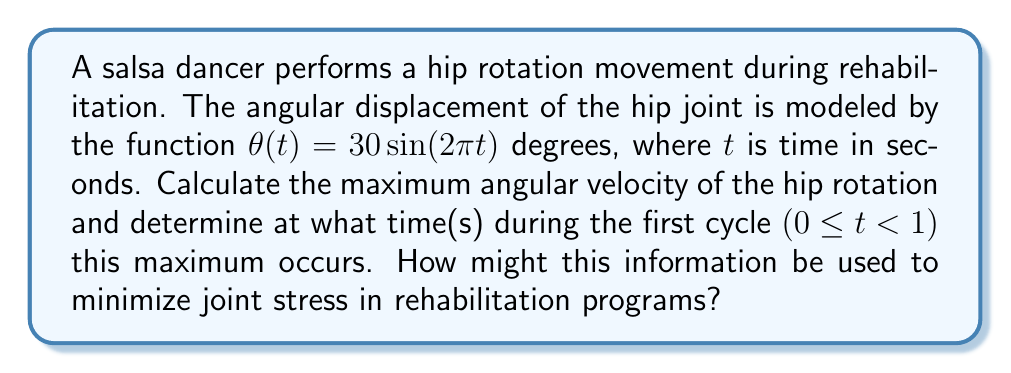Give your solution to this math problem. To solve this problem, we'll follow these steps:

1) First, we need to find the angular velocity function. Angular velocity is the derivative of angular displacement with respect to time.

   $$\omega(t) = \frac{d\theta}{dt} = 30 \cdot 2\pi \cos(2\pi t) = 60\pi \cos(2\pi t)$$ degrees/second

2) To find the maximum angular velocity, we need to find the maximum absolute value of this function. The cosine function oscillates between -1 and 1, so the maximum absolute value will occur when $\cos(2\pi t) = \pm 1$.

3) The maximum angular velocity is therefore:

   $$|\omega_{max}| = 60\pi$$ degrees/second

4) To find when this maximum occurs, we solve:

   $\cos(2\pi t) = \pm 1$

   This occurs when $2\pi t = 0, \pi, 2\pi, ...$ for positive maxima, and when $2\pi t = \pi/2, 3\pi/2, ...$ for negative maxima.

5) Solving for t in the first cycle (0 ≤ t < 1):

   Positive maximum: $t = 0$
   Negative maximum: $t = 1/4$

6) Converting the maximum angular velocity to radians per second:

   $$\omega_{max} = 60\pi \cdot \frac{\pi}{180} = \pi^2$$ radians/second

This information can be used in rehabilitation programs to ensure that the angular velocity of hip rotations doesn't exceed this maximum value, thereby minimizing joint stress. By knowing the times at which these maximum velocities occur, therapists can design exercises that avoid prolonged periods at these high-stress points.
Answer: The maximum angular velocity is $\pi^2$ radians/second (or $60\pi$ degrees/second), occurring at $t = 0$ and $t = 1/4$ seconds in the first cycle. 